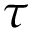Convert formula to latex. <formula><loc_0><loc_0><loc_500><loc_500>\tau</formula> 